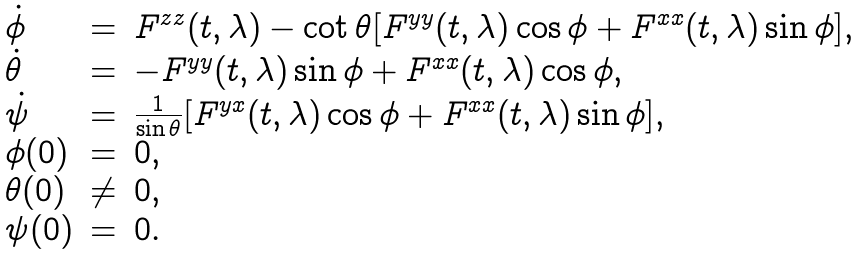Convert formula to latex. <formula><loc_0><loc_0><loc_500><loc_500>\begin{array} { l l l } \dot { \phi } & = & F ^ { z z } ( t , \lambda ) - \cot \theta [ F ^ { y y } ( t , \lambda ) \cos \phi + F ^ { x x } ( t , \lambda ) \sin \phi ] , \\ \dot { \theta } & = & - F ^ { y y } ( t , \lambda ) \sin \phi + F ^ { x x } ( t , \lambda ) \cos \phi , \\ \dot { \psi } & = & \frac { 1 } { \sin \theta } [ F ^ { y x } ( t , \lambda ) \cos \phi + F ^ { x x } ( t , \lambda ) \sin \phi ] , \\ \phi ( 0 ) & = & 0 , \\ \theta ( 0 ) & \neq & 0 , \\ \psi ( 0 ) & = & 0 . \end{array}</formula> 